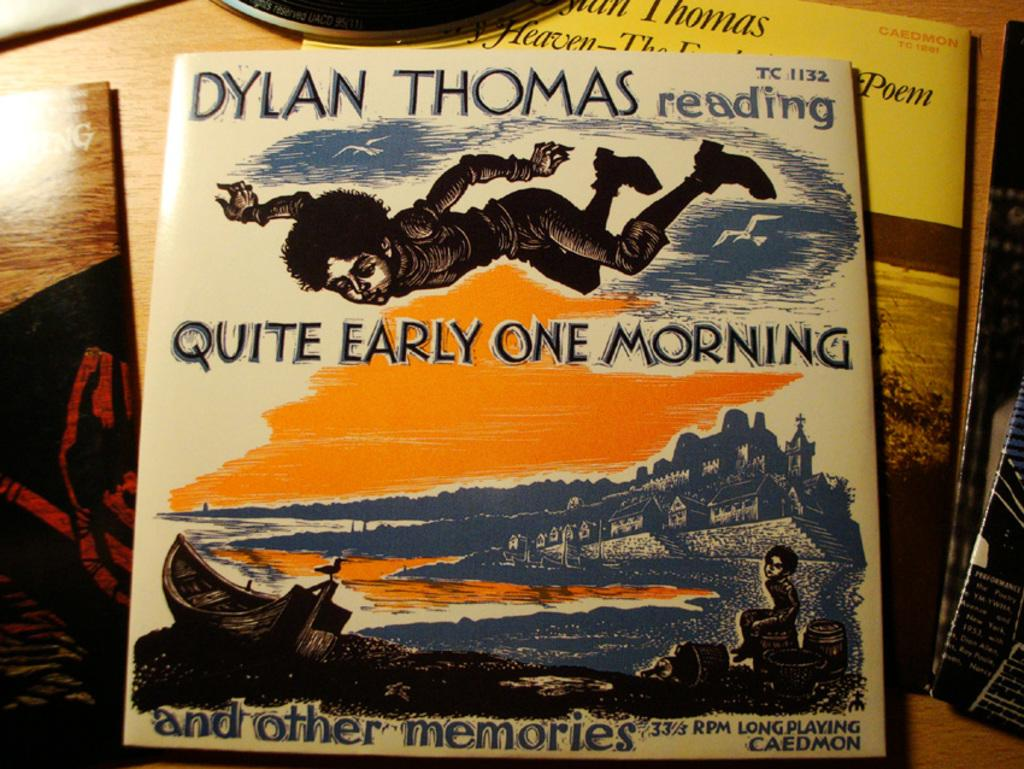<image>
Provide a brief description of the given image. Poetry books are read on records by Dylan Thomas. 